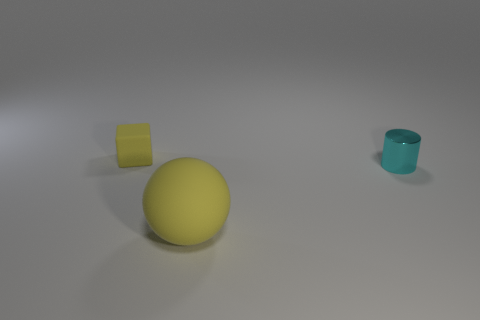How many other things are there of the same color as the tiny rubber object?
Your answer should be very brief. 1. Is the size of the thing in front of the tiny cyan object the same as the cyan thing that is on the right side of the cube?
Ensure brevity in your answer.  No. Does the cube have the same material as the small object on the right side of the tiny matte cube?
Provide a short and direct response. No. Are there more yellow rubber cubes behind the cyan metallic thing than rubber objects that are in front of the big yellow thing?
Give a very brief answer. Yes. There is a matte object to the right of the matte thing behind the large yellow ball; what is its color?
Make the answer very short. Yellow. How many spheres are big red objects or small cyan metal things?
Your answer should be compact. 0. What number of small objects are on the left side of the metallic thing and in front of the small yellow rubber thing?
Ensure brevity in your answer.  0. There is a big ball that is in front of the cylinder; what is its color?
Provide a succinct answer. Yellow. What size is the yellow cube that is made of the same material as the yellow sphere?
Your answer should be very brief. Small. How many tiny yellow matte objects are to the right of the yellow object that is in front of the cyan shiny object?
Give a very brief answer. 0. 